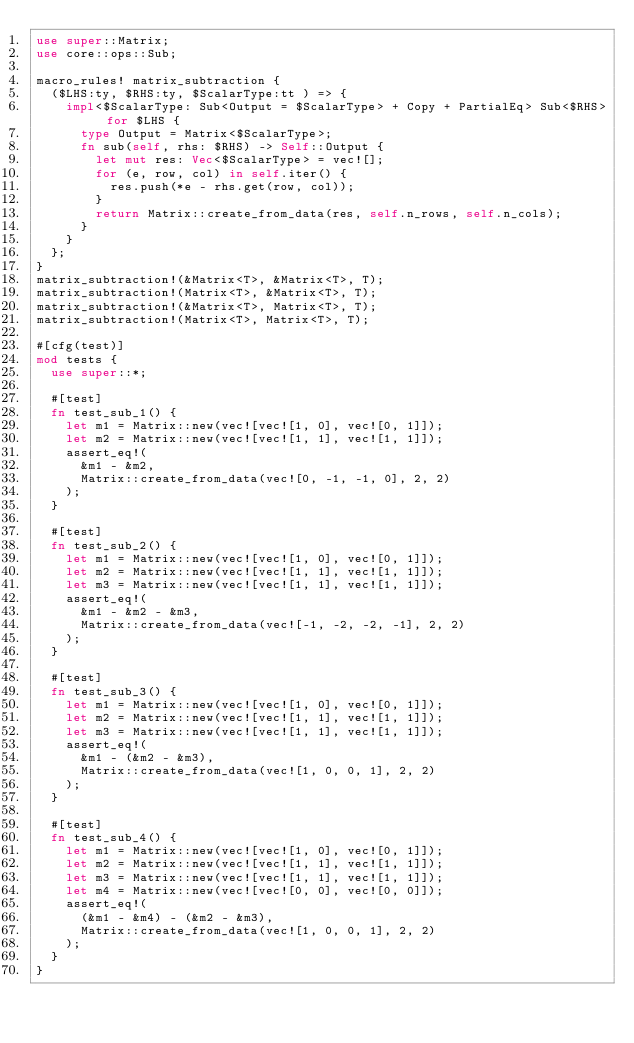<code> <loc_0><loc_0><loc_500><loc_500><_Rust_>use super::Matrix;
use core::ops::Sub;

macro_rules! matrix_subtraction {
  ($LHS:ty, $RHS:ty, $ScalarType:tt ) => {
    impl<$ScalarType: Sub<Output = $ScalarType> + Copy + PartialEq> Sub<$RHS> for $LHS {
      type Output = Matrix<$ScalarType>;
      fn sub(self, rhs: $RHS) -> Self::Output {
        let mut res: Vec<$ScalarType> = vec![];
        for (e, row, col) in self.iter() {
          res.push(*e - rhs.get(row, col));
        }
        return Matrix::create_from_data(res, self.n_rows, self.n_cols);
      }
    }
  };
}
matrix_subtraction!(&Matrix<T>, &Matrix<T>, T);
matrix_subtraction!(Matrix<T>, &Matrix<T>, T);
matrix_subtraction!(&Matrix<T>, Matrix<T>, T);
matrix_subtraction!(Matrix<T>, Matrix<T>, T);

#[cfg(test)]
mod tests {
  use super::*;

  #[test]
  fn test_sub_1() {
    let m1 = Matrix::new(vec![vec![1, 0], vec![0, 1]]);
    let m2 = Matrix::new(vec![vec![1, 1], vec![1, 1]]);
    assert_eq!(
      &m1 - &m2,
      Matrix::create_from_data(vec![0, -1, -1, 0], 2, 2)
    );
  }

  #[test]
  fn test_sub_2() {
    let m1 = Matrix::new(vec![vec![1, 0], vec![0, 1]]);
    let m2 = Matrix::new(vec![vec![1, 1], vec![1, 1]]);
    let m3 = Matrix::new(vec![vec![1, 1], vec![1, 1]]);
    assert_eq!(
      &m1 - &m2 - &m3,
      Matrix::create_from_data(vec![-1, -2, -2, -1], 2, 2)
    );
  }

  #[test]
  fn test_sub_3() {
    let m1 = Matrix::new(vec![vec![1, 0], vec![0, 1]]);
    let m2 = Matrix::new(vec![vec![1, 1], vec![1, 1]]);
    let m3 = Matrix::new(vec![vec![1, 1], vec![1, 1]]);
    assert_eq!(
      &m1 - (&m2 - &m3),
      Matrix::create_from_data(vec![1, 0, 0, 1], 2, 2)
    );
  }

  #[test]
  fn test_sub_4() {
    let m1 = Matrix::new(vec![vec![1, 0], vec![0, 1]]);
    let m2 = Matrix::new(vec![vec![1, 1], vec![1, 1]]);
    let m3 = Matrix::new(vec![vec![1, 1], vec![1, 1]]);
    let m4 = Matrix::new(vec![vec![0, 0], vec![0, 0]]);
    assert_eq!(
      (&m1 - &m4) - (&m2 - &m3),
      Matrix::create_from_data(vec![1, 0, 0, 1], 2, 2)
    );
  }
}
</code> 